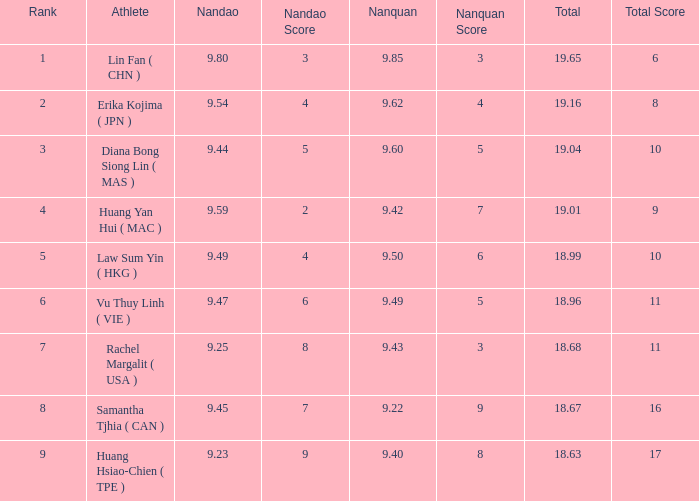Which Nanquan has a Nandao larger than 9.49, and a Rank of 4? 9.42. 